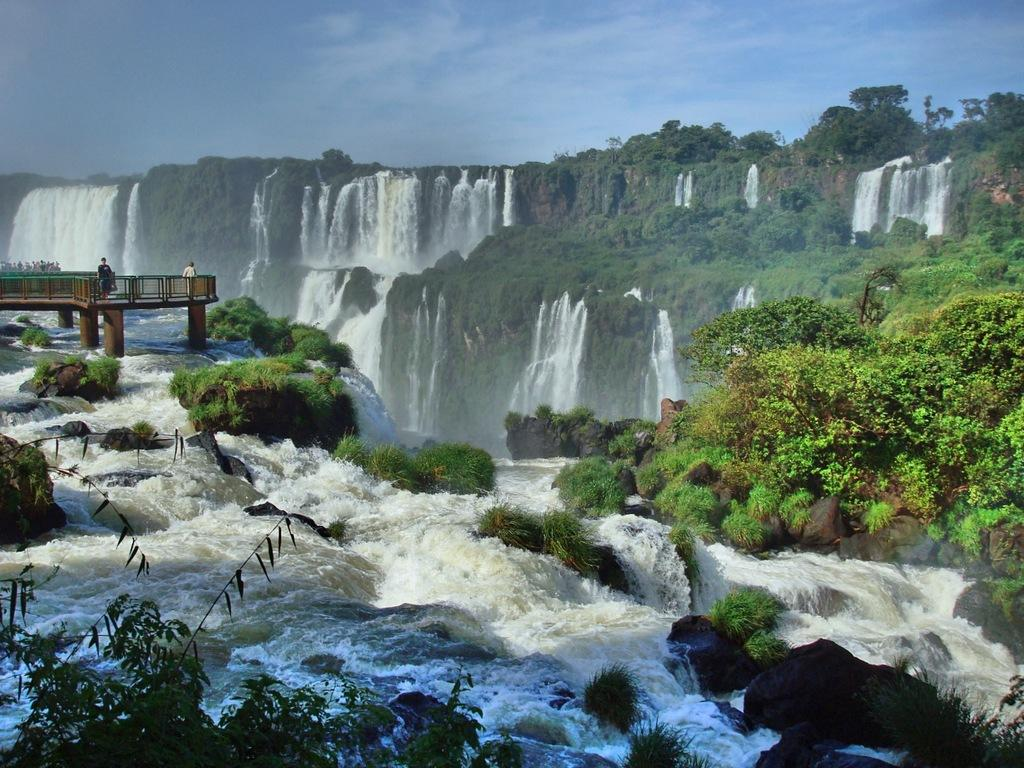What natural feature can be seen in the image? There are waterfalls in the image. What type of vegetation is present in the image? There are trees in the image. What man-made structure is visible in the image? There is a bridge in the image. Are there any people in the image? Yes, two persons are standing on the bridge. What type of underwear is hanging on the trees in the image? There is no underwear present in the image; it only features waterfalls, trees, a bridge, and two persons standing on the bridge. 